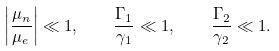Convert formula to latex. <formula><loc_0><loc_0><loc_500><loc_500>\left | \frac { \mu _ { n } } { \mu _ { e } } \right | \ll 1 , \quad \frac { \Gamma _ { 1 } } { \gamma _ { 1 } } \ll 1 , \quad \frac { \Gamma _ { 2 } } { \gamma _ { 2 } } \ll 1 .</formula> 